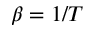<formula> <loc_0><loc_0><loc_500><loc_500>\beta = 1 / T</formula> 